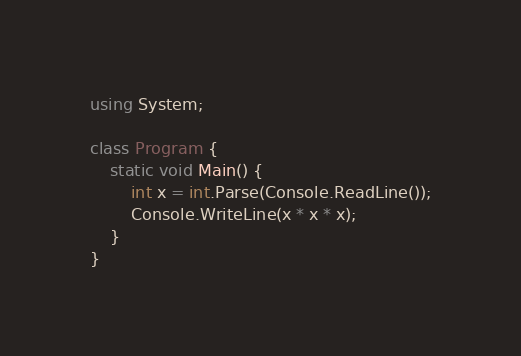<code> <loc_0><loc_0><loc_500><loc_500><_C#_>using System;

class Program {
    static void Main() {
        int x = int.Parse(Console.ReadLine());
        Console.WriteLine(x * x * x);
    }
}</code> 